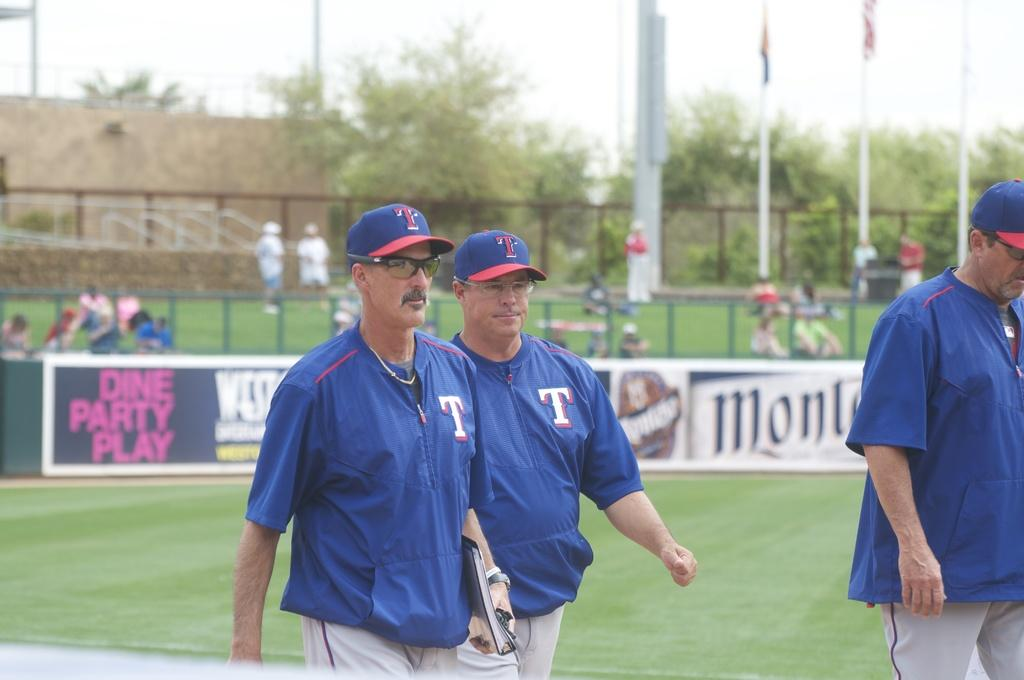<image>
Provide a brief description of the given image. Several men walk across a baseball field with a sign that says Dine Party Play in the background. 